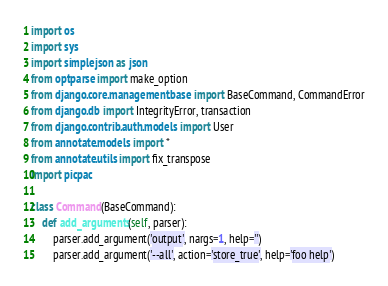Convert code to text. <code><loc_0><loc_0><loc_500><loc_500><_Python_>import os
import sys
import simplejson as json
from optparse import make_option
from django.core.management.base import BaseCommand, CommandError
from django.db import IntegrityError, transaction
from django.contrib.auth.models import User
from annotate.models import *
from annotate.utils import fix_transpose
import picpac

class Command(BaseCommand):
    def add_arguments(self, parser):
        parser.add_argument('output', nargs=1, help='')
        parser.add_argument('--all', action='store_true', help='foo help')</code> 